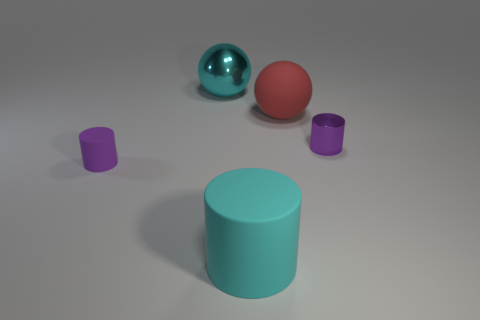Subtract all green spheres. How many purple cylinders are left? 2 Subtract all small purple cylinders. How many cylinders are left? 1 Add 5 large cyan objects. How many objects exist? 10 Subtract all cylinders. How many objects are left? 2 Subtract 0 purple cubes. How many objects are left? 5 Subtract all cyan shiny objects. Subtract all purple objects. How many objects are left? 2 Add 3 purple metal things. How many purple metal things are left? 4 Add 3 balls. How many balls exist? 5 